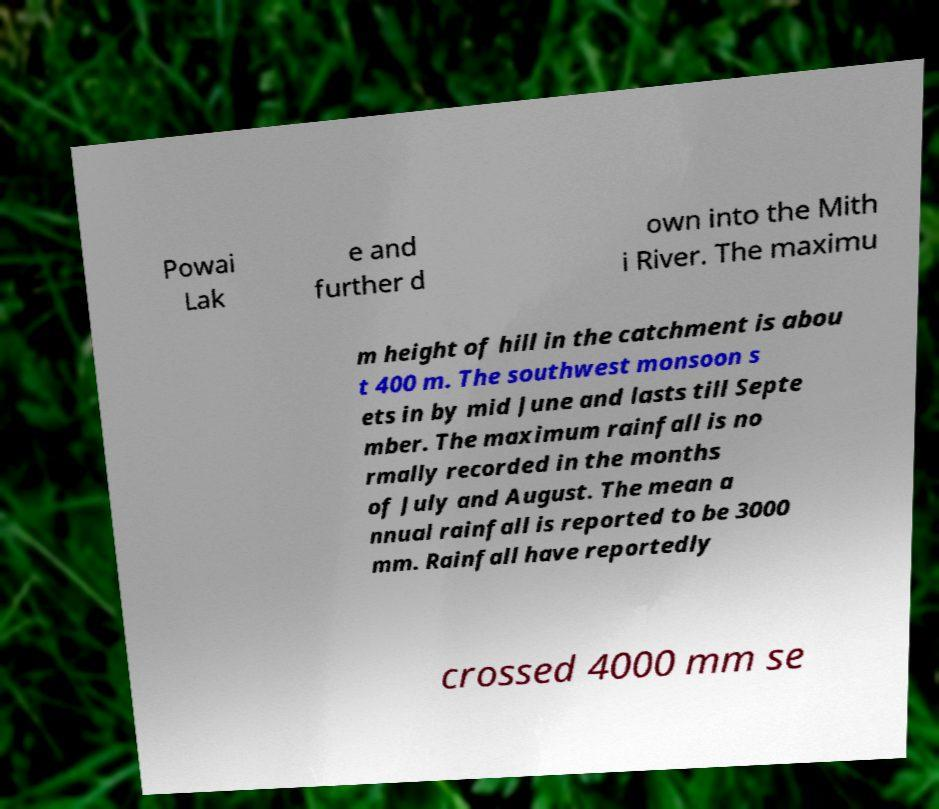For documentation purposes, I need the text within this image transcribed. Could you provide that? Powai Lak e and further d own into the Mith i River. The maximu m height of hill in the catchment is abou t 400 m. The southwest monsoon s ets in by mid June and lasts till Septe mber. The maximum rainfall is no rmally recorded in the months of July and August. The mean a nnual rainfall is reported to be 3000 mm. Rainfall have reportedly crossed 4000 mm se 